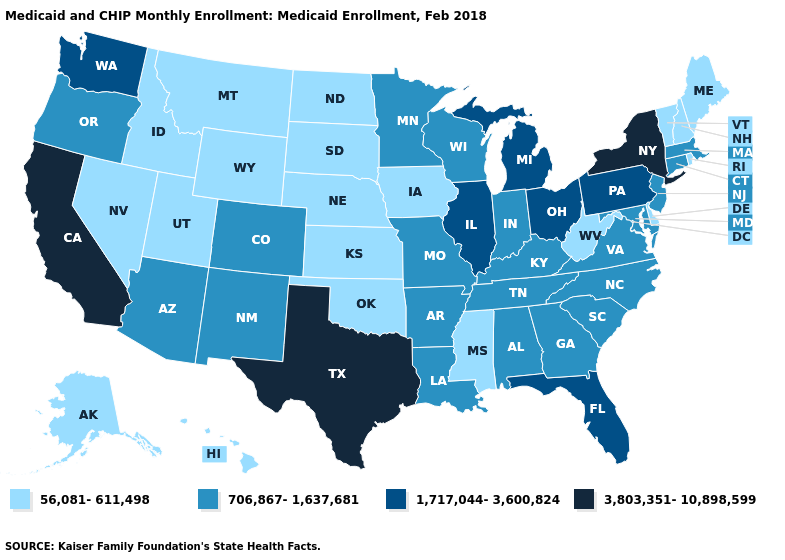Does Oklahoma have a lower value than West Virginia?
Quick response, please. No. What is the lowest value in the Northeast?
Quick response, please. 56,081-611,498. What is the lowest value in the USA?
Answer briefly. 56,081-611,498. Name the states that have a value in the range 1,717,044-3,600,824?
Be succinct. Florida, Illinois, Michigan, Ohio, Pennsylvania, Washington. Name the states that have a value in the range 706,867-1,637,681?
Give a very brief answer. Alabama, Arizona, Arkansas, Colorado, Connecticut, Georgia, Indiana, Kentucky, Louisiana, Maryland, Massachusetts, Minnesota, Missouri, New Jersey, New Mexico, North Carolina, Oregon, South Carolina, Tennessee, Virginia, Wisconsin. Which states hav the highest value in the Northeast?
Give a very brief answer. New York. How many symbols are there in the legend?
Short answer required. 4. Name the states that have a value in the range 1,717,044-3,600,824?
Write a very short answer. Florida, Illinois, Michigan, Ohio, Pennsylvania, Washington. Does the first symbol in the legend represent the smallest category?
Keep it brief. Yes. Name the states that have a value in the range 56,081-611,498?
Be succinct. Alaska, Delaware, Hawaii, Idaho, Iowa, Kansas, Maine, Mississippi, Montana, Nebraska, Nevada, New Hampshire, North Dakota, Oklahoma, Rhode Island, South Dakota, Utah, Vermont, West Virginia, Wyoming. Name the states that have a value in the range 1,717,044-3,600,824?
Be succinct. Florida, Illinois, Michigan, Ohio, Pennsylvania, Washington. What is the highest value in the USA?
Write a very short answer. 3,803,351-10,898,599. Name the states that have a value in the range 56,081-611,498?
Quick response, please. Alaska, Delaware, Hawaii, Idaho, Iowa, Kansas, Maine, Mississippi, Montana, Nebraska, Nevada, New Hampshire, North Dakota, Oklahoma, Rhode Island, South Dakota, Utah, Vermont, West Virginia, Wyoming. Does Colorado have the same value as Oregon?
Give a very brief answer. Yes. What is the lowest value in the West?
Concise answer only. 56,081-611,498. 